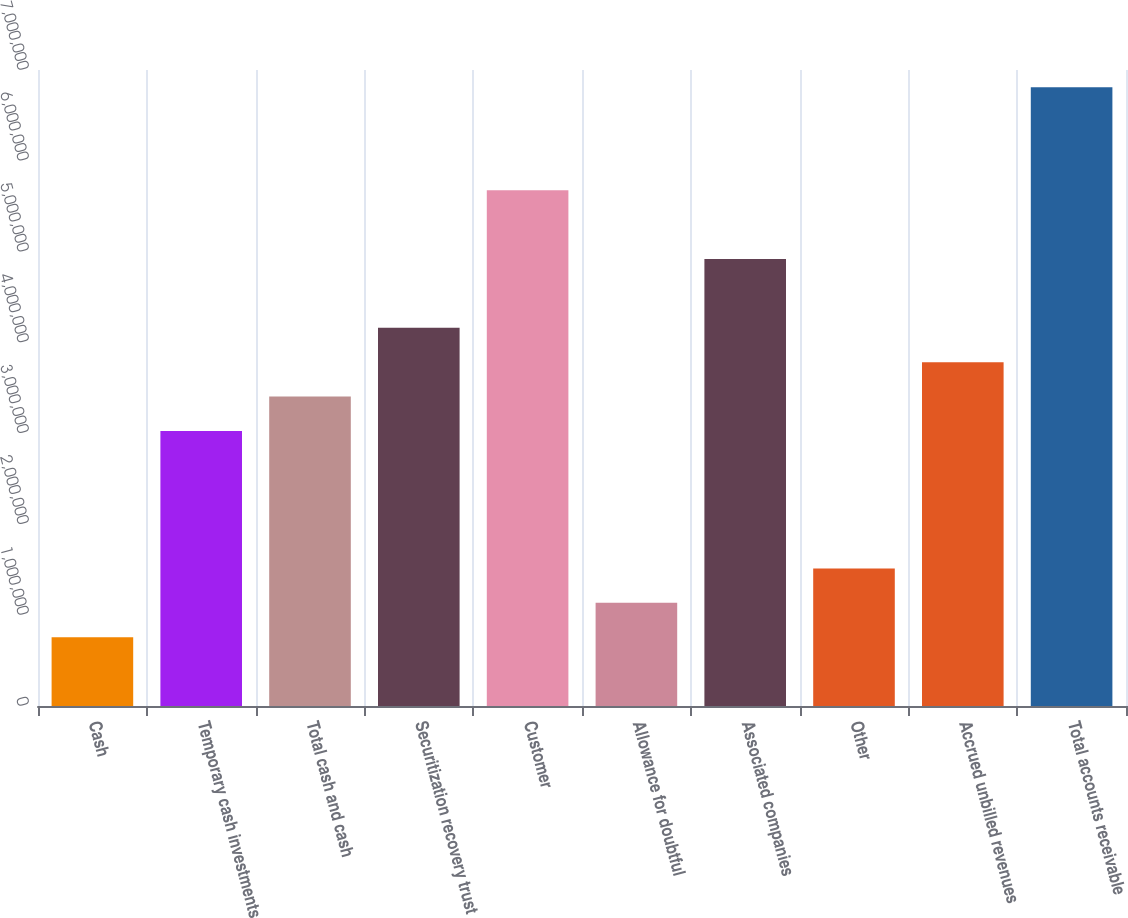Convert chart. <chart><loc_0><loc_0><loc_500><loc_500><bar_chart><fcel>Cash<fcel>Temporary cash investments<fcel>Total cash and cash<fcel>Securitization recovery trust<fcel>Customer<fcel>Allowance for doubtful<fcel>Associated companies<fcel>Other<fcel>Accrued unbilled revenues<fcel>Total accounts receivable<nl><fcel>757422<fcel>3.02725e+06<fcel>3.40556e+06<fcel>4.16217e+06<fcel>5.67539e+06<fcel>1.13573e+06<fcel>4.91878e+06<fcel>1.51403e+06<fcel>3.78386e+06<fcel>6.81031e+06<nl></chart> 